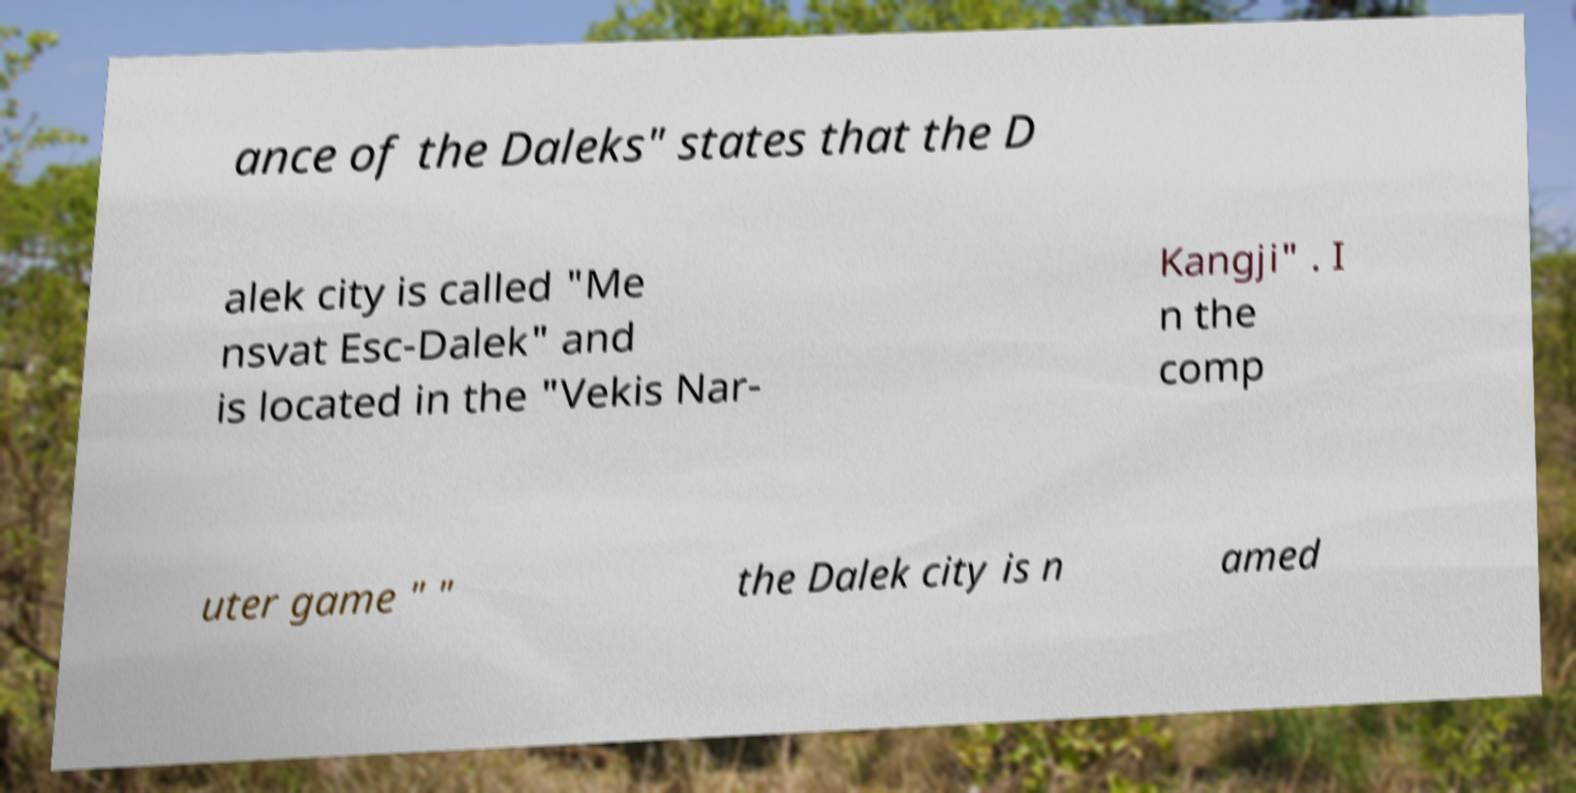I need the written content from this picture converted into text. Can you do that? ance of the Daleks" states that the D alek city is called "Me nsvat Esc-Dalek" and is located in the "Vekis Nar- Kangji" . I n the comp uter game " " the Dalek city is n amed 